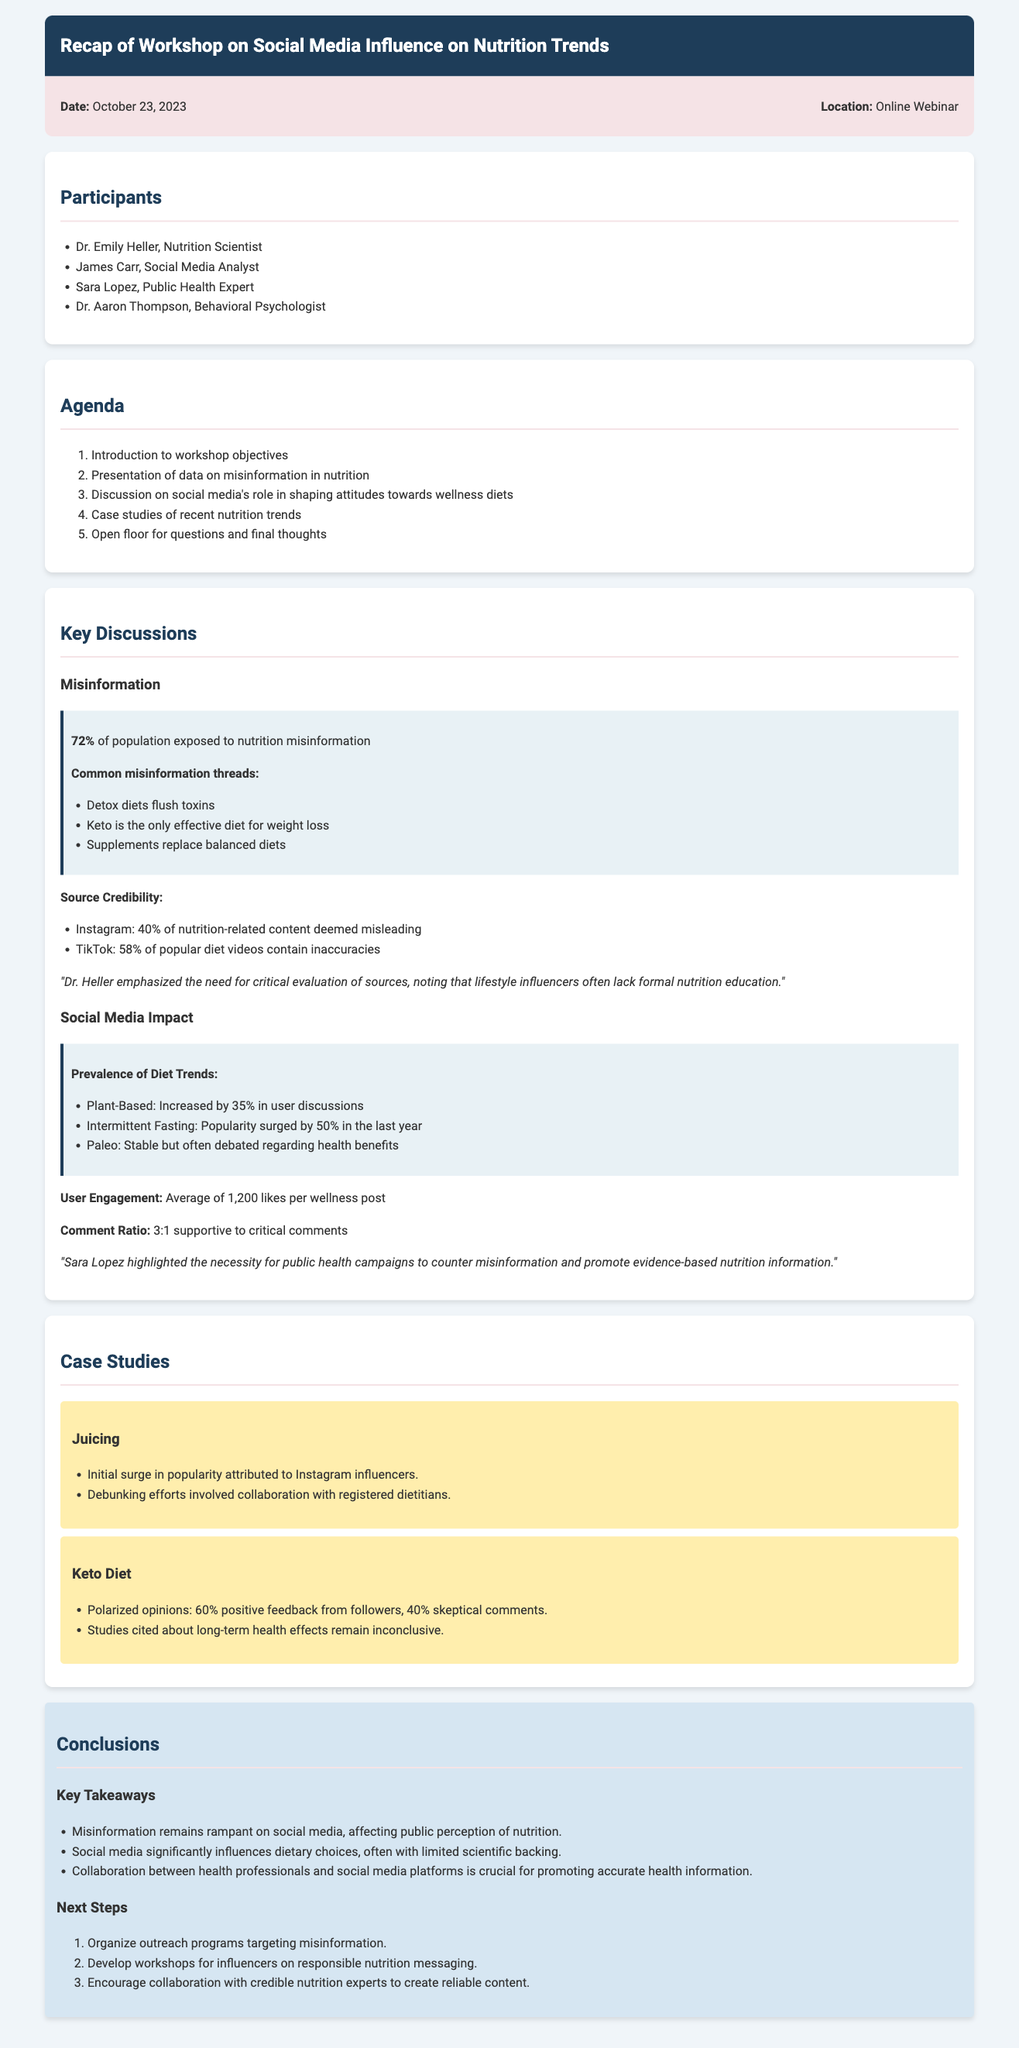What was the date of the workshop? The date of the workshop is stated in the document.
Answer: October 23, 2023 Who presented data on misinformation in nutrition? Dr. Heller is mentioned as emphasizing the need for critical evaluation of sources regarding misinformation.
Answer: Dr. Emily Heller What percentage of the population is exposed to nutrition misinformation? This percentage is provided directly in the key discussions section.
Answer: 72% Which social media platform had 40% of nutrition-related content deemed misleading? The document specifies the credibility of information from different platforms.
Answer: Instagram What is the average number of likes per wellness post? The document provides a specific statistic related to user engagement.
Answer: 1,200 likes How did user comments compare in terms of support and criticism? The document states the comment ratio, which reflects user engagement.
Answer: 3:1 supportive to critical comments What were the conclusions about misinformation? The document outlines key takeaways including the impact of misinformation on public perception.
Answer: Misinformation remains rampant on social media What was one of the next steps mentioned in the conclusions? The next steps section includes various actions to take regarding misinformation.
Answer: Organize outreach programs targeting misinformation 